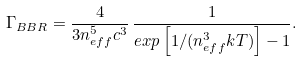Convert formula to latex. <formula><loc_0><loc_0><loc_500><loc_500>\Gamma _ { B B R } = \frac { 4 } { 3 n _ { e f f } ^ { 5 } c ^ { 3 } } \, \frac { 1 } { e x p \left [ 1 / ( n _ { e f f } ^ { 3 } k T ) \right ] - 1 } .</formula> 